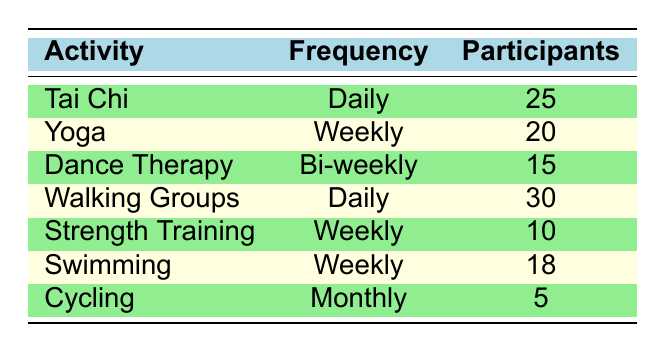What is the total number of participants in Tai Chi? The table shows that the number of participants in Tai Chi is listed directly, which is 25.
Answer: 25 How many participants are involved in weekly strength training? The table lists strength training under the weekly frequency, and the number of participants is indicated as 10.
Answer: 10 Which movement activity has the most participants? By comparing the participant numbers across all activities, Walking Groups has the highest number at 30 participants.
Answer: Walking Groups What is the total number of participants who do Yoga and Swimming combined? Yoga has 20 participants and Swimming has 18 participants. Adding these gives us 20 + 18 = 38 participants combined.
Answer: 38 Are there more participants in Dance Therapy than in Cycling? Dance Therapy has 15 participants while Cycling has 5 participants. Since 15 > 5, the statement is true.
Answer: Yes What is the frequency of the movement activity that has 18 participants? The table shows Swimming has 18 participants and its frequency is listed as Weekly.
Answer: Weekly What is the average number of participants across all activities? The total number of participants is 25 (Tai Chi) + 20 (Yoga) + 15 (Dance Therapy) + 30 (Walking Groups) + 10 (Strength Training) + 18 (Swimming) + 5 (Cycling) = 123 participants. Since there are 7 activities, the average is 123 / 7 ≈ 17.57.
Answer: 17.57 Do more individuals participate in Daily activities than Weekly activities? Daily activities (Tai Chi and Walking Groups) have 25 + 30 = 55 participants. Weekly activities (Yoga, Strength Training, and Swimming) have 20 + 10 + 18 = 48 participants. Therefore, 55 > 48, making the statement true.
Answer: Yes What is the difference in participants between the most and least attended activities? The most attended activity is Walking Groups with 30 participants, and the least is Cycling with 5 participants. The difference is 30 - 5 = 25.
Answer: 25 